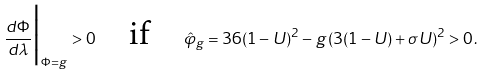Convert formula to latex. <formula><loc_0><loc_0><loc_500><loc_500>\frac { d \Phi } { d \lambda } \Big | _ { \Phi = g } > 0 \quad \text {if} \quad \hat { \varphi } _ { g } = 3 6 ( 1 - U ) ^ { 2 } - g \, ( 3 ( 1 - U ) + \sigma U ) ^ { 2 } > 0 \, .</formula> 